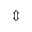Convert formula to latex. <formula><loc_0><loc_0><loc_500><loc_500>\Updownarrow</formula> 